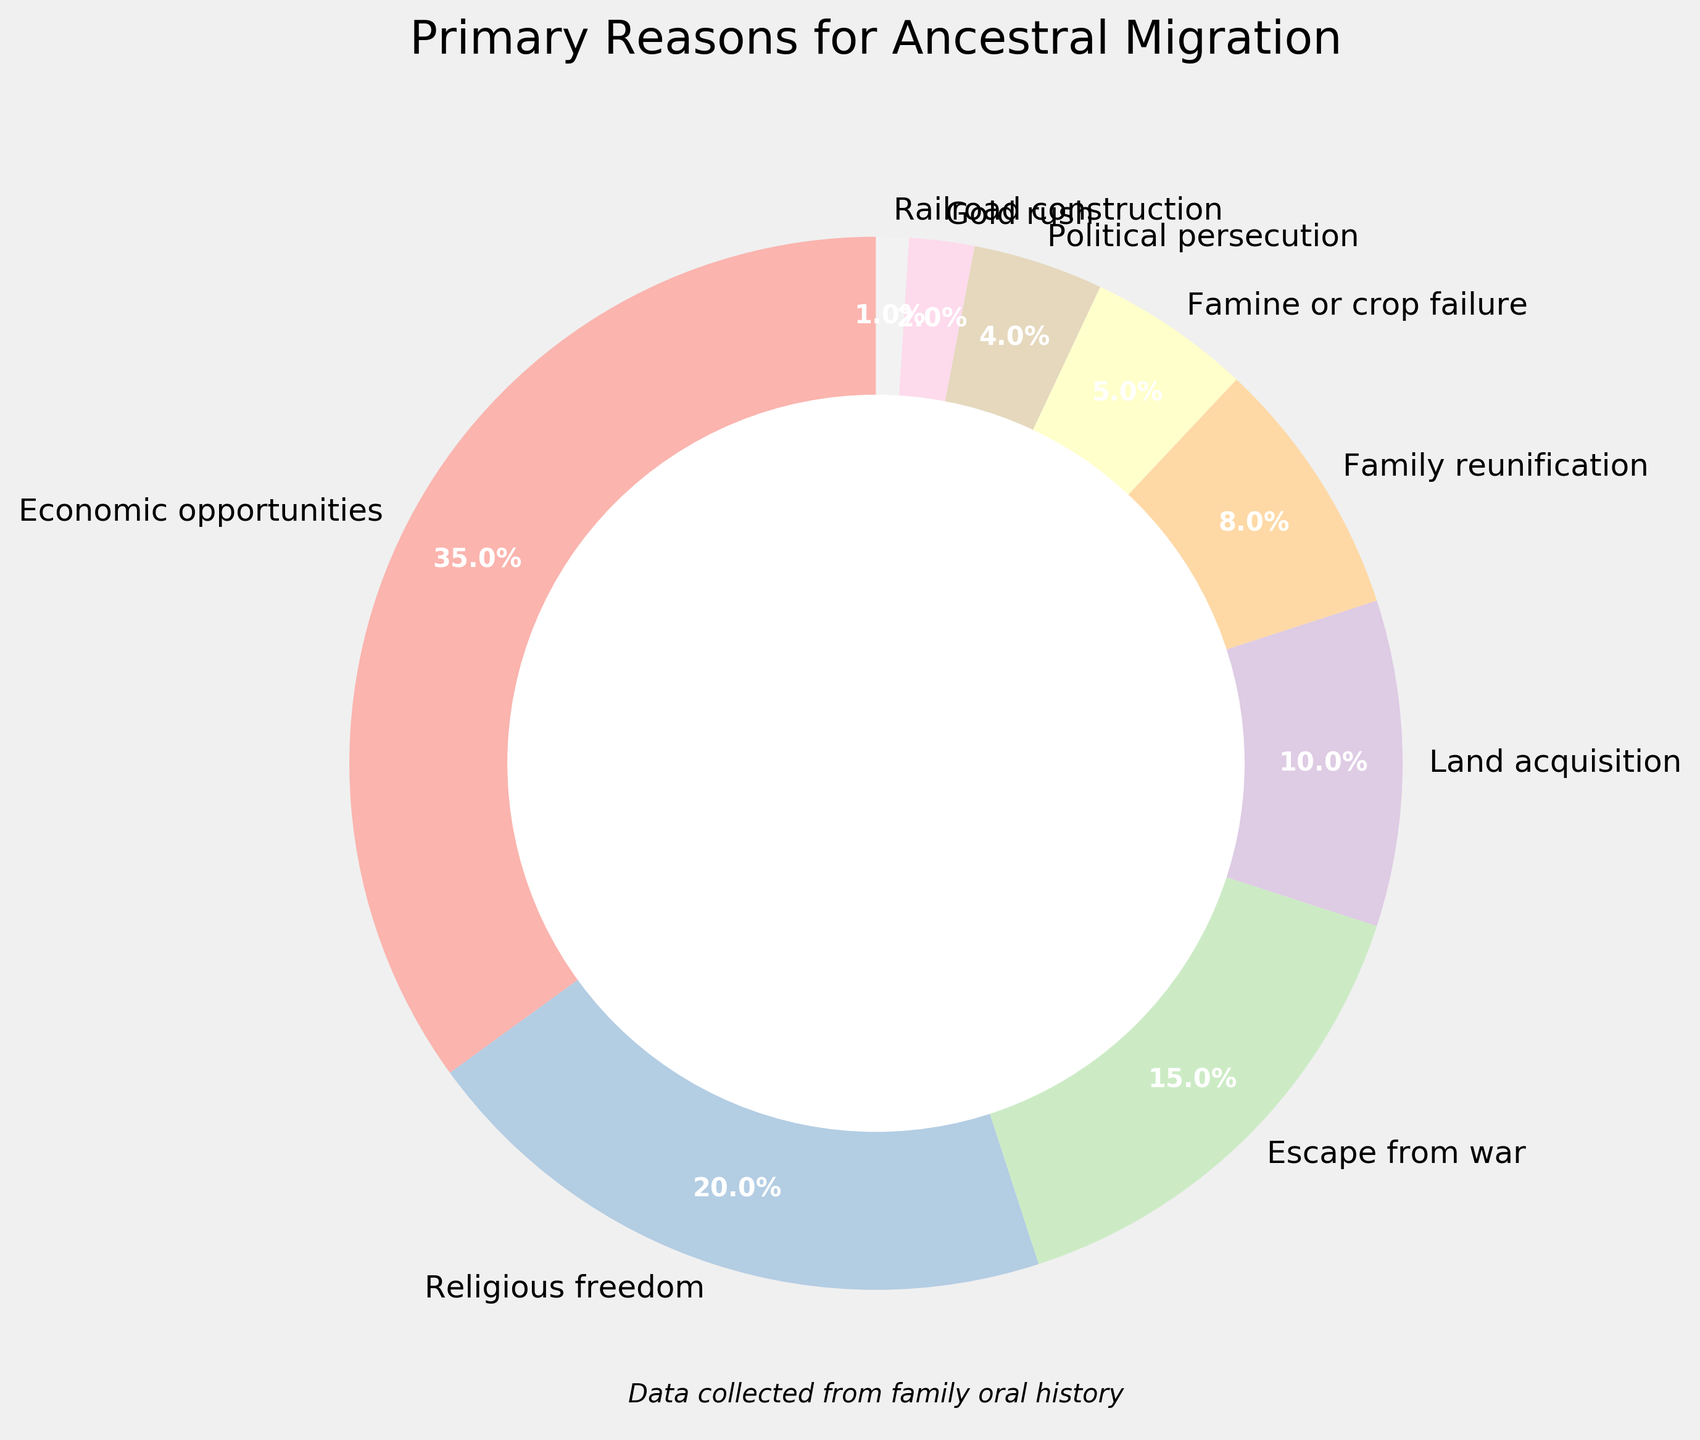What is the largest reason for ancestral migration according to the pie chart? The largest segment in the pie chart, representing 35%, corresponds to "Economic opportunities", which is the primary reason for ancestral migration.
Answer: Economic opportunities Which reason is cited less frequently than religious freedom but more frequently than family reunification? "Escape from war" is cited by 15% of ancestors, which is less frequent than "Religious freedom" (20%) but more frequent than "Family reunification" (8%).
Answer: Escape from war What is the combined percentage of ancestors who migrated for Economic opportunities and Land acquisition? The percentage for Economic opportunities is 35% and for Land acquisition is 10%. Adding these together results in 35% + 10% = 45%.
Answer: 45% Which reason accounts for a smaller percentage than Famine or crop failure but a larger percentage than Railroad construction? "Political persecution" accounts for 4%, which is smaller than "Famine or crop failure" (5%) but larger than "Railroad construction" (1%).
Answer: Political persecution How much more frequent was Economic opportunities as a reason compared to Political persecution? Economic opportunities, at 35%, was cited 35 - 4 = 31% more often than Political persecution, which was cited by 4% of ancestors.
Answer: 31% Which two reasons together account for an equal or larger percentage than Escape from war? "Religious freedom" (20%) and "Family reunification" (8%) together account for 20% + 8% = 28%, which is larger than Escape from war's 15%.
Answer: Religious freedom and Family reunification What percentage of reasons are cited less frequently than Family reunification? The reasons cited less frequently than Family reunification (8%) are "Famine or crop failure" (5%), "Political persecution" (4%), "Gold rush" (2%), and "Railroad construction" (1%). Summing these up, 5% + 4% + 2% + 1% = 12%.
Answer: 12% How many reasons are cited less frequently than 5%? "Gold rush" with 2% and "Railroad construction" with 1% are the reasons cited less frequently than 5%. Hence, there are 2 reasons.
Answer: 2 Which reason appears in the smallest segment of the pie chart? The smallest segment of the pie chart represents "Railroad construction", which accounts for 1% of ancestral migration reasons.
Answer: Railroad construction 